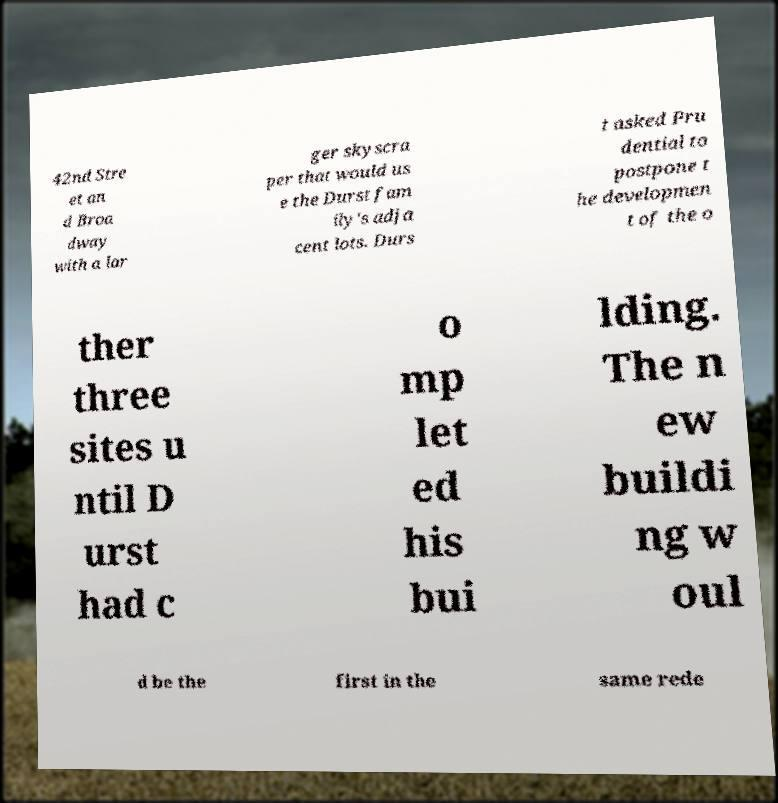What messages or text are displayed in this image? I need them in a readable, typed format. 42nd Stre et an d Broa dway with a lar ger skyscra per that would us e the Durst fam ily's adja cent lots. Durs t asked Pru dential to postpone t he developmen t of the o ther three sites u ntil D urst had c o mp let ed his bui lding. The n ew buildi ng w oul d be the first in the same rede 